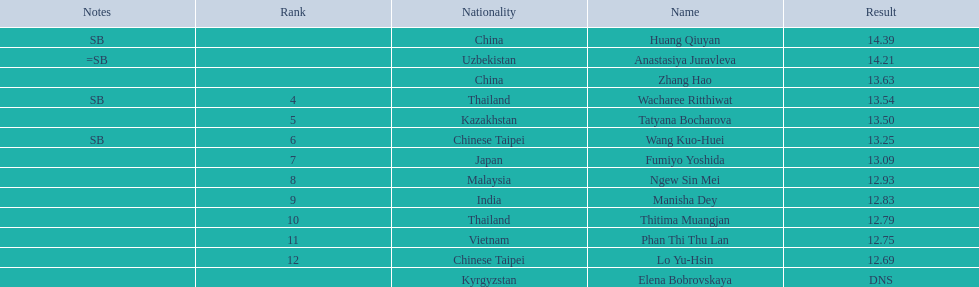How many points apart were the 1st place competitor and the 12th place competitor? 1.7. 